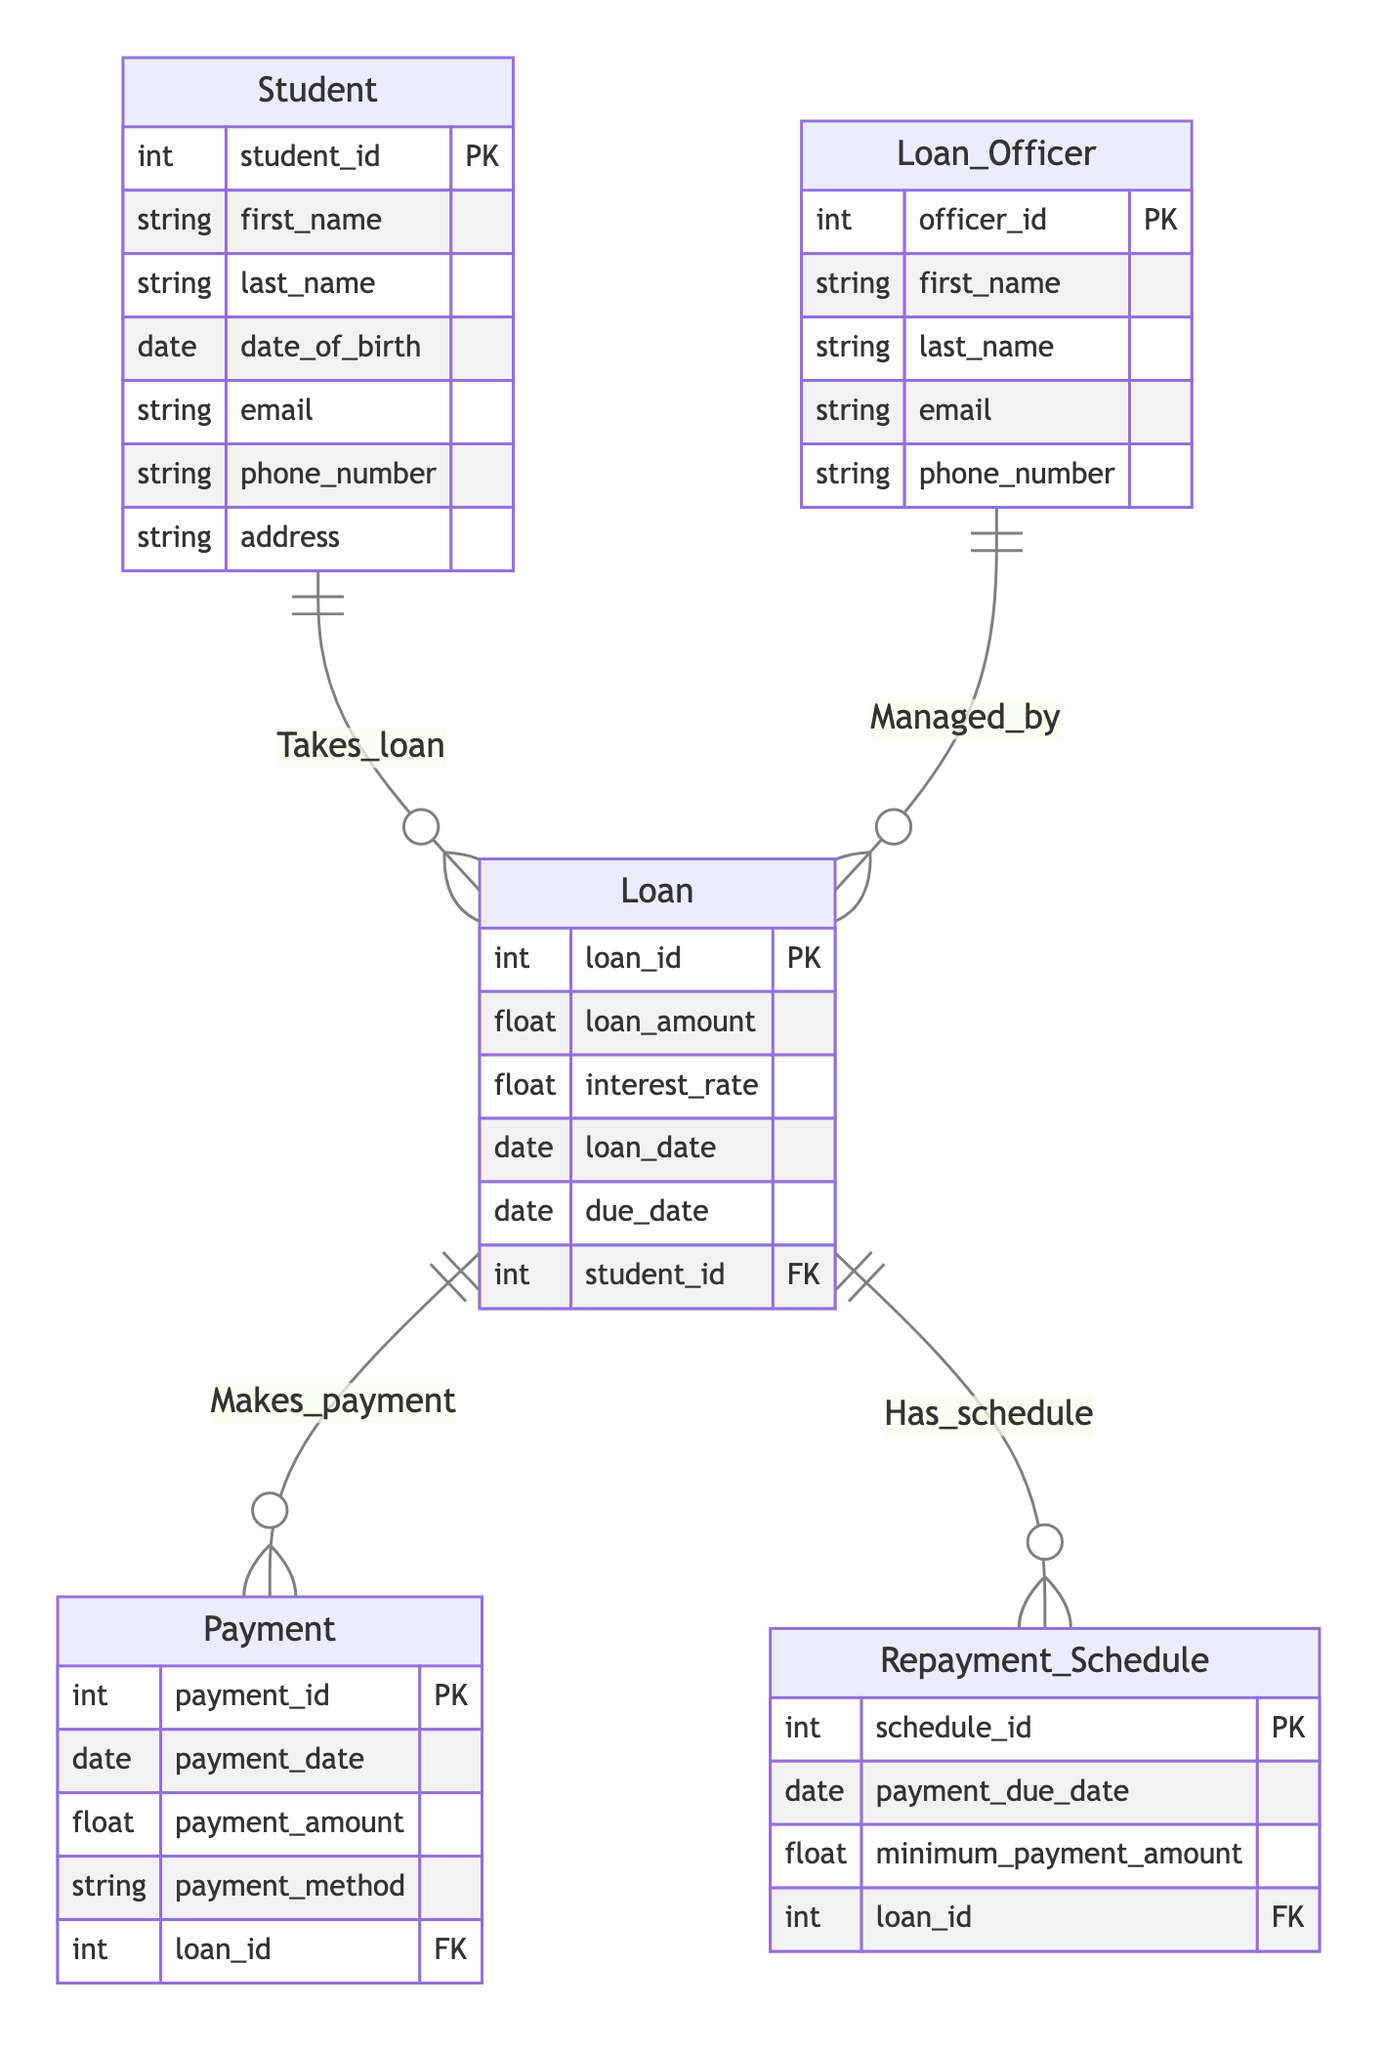What are the primary entities in this diagram? The diagram contains five primary entities: Student, Loan, Payment, Repayment Schedule, and Loan Officer.
Answer: Student, Loan, Payment, Repayment Schedule, Loan Officer How many attributes does the Loan entity have? Upon examining the Loan entity, it is clear that it has five attributes: loan_id, loan_amount, interest_rate, loan_date, and due_date.
Answer: 5 What is the maximum number of loans a single student can have? The relationship between Student and Loan shows that a single student can take 0 to many loans, indicated by the multiplicity "0..*". Hence, the maximum number of loans is unlimited.
Answer: Unlimited Which entity manages the Loan? The relationship named "Managed_by" indicates that the Loan Officer entity manages the Loan entity, with a one-to-many relationship.
Answer: Loan Officer What is the minimum number of payments made for a Loan? The relationship "Makes_payment" shows that a Loan can have zero or more payments associated with it, indicated by the multiplicity "0..*". Thus, a Loan can exist without any payments.
Answer: 0 How many Loan Officers can manage a single Loan? The relationship "Managed_by" specifies that each Loan is managed by exactly one Loan Officer, which is denoted by the multiplicity "1".
Answer: 1 What relationship connects the Student and Loan entities? The relationship connecting the Student and Loan entities is called "Takes_loan", which signifies that students can take out loans.
Answer: Takes_loan What is required to link a Payment to a Loan? To link a Payment to a Loan, a payment must include the loan_id which serves as a foreign key in the Payment entity, ensuring that each payment is associated with a specific loan.
Answer: loan_id How many Payment entities can be associated with a single Loan? According to the relationship "Makes_payment", a single Loan can have 0 or more Payment entities associated with it, meaning there can be unlimited payments for one loan.
Answer: Unlimited 